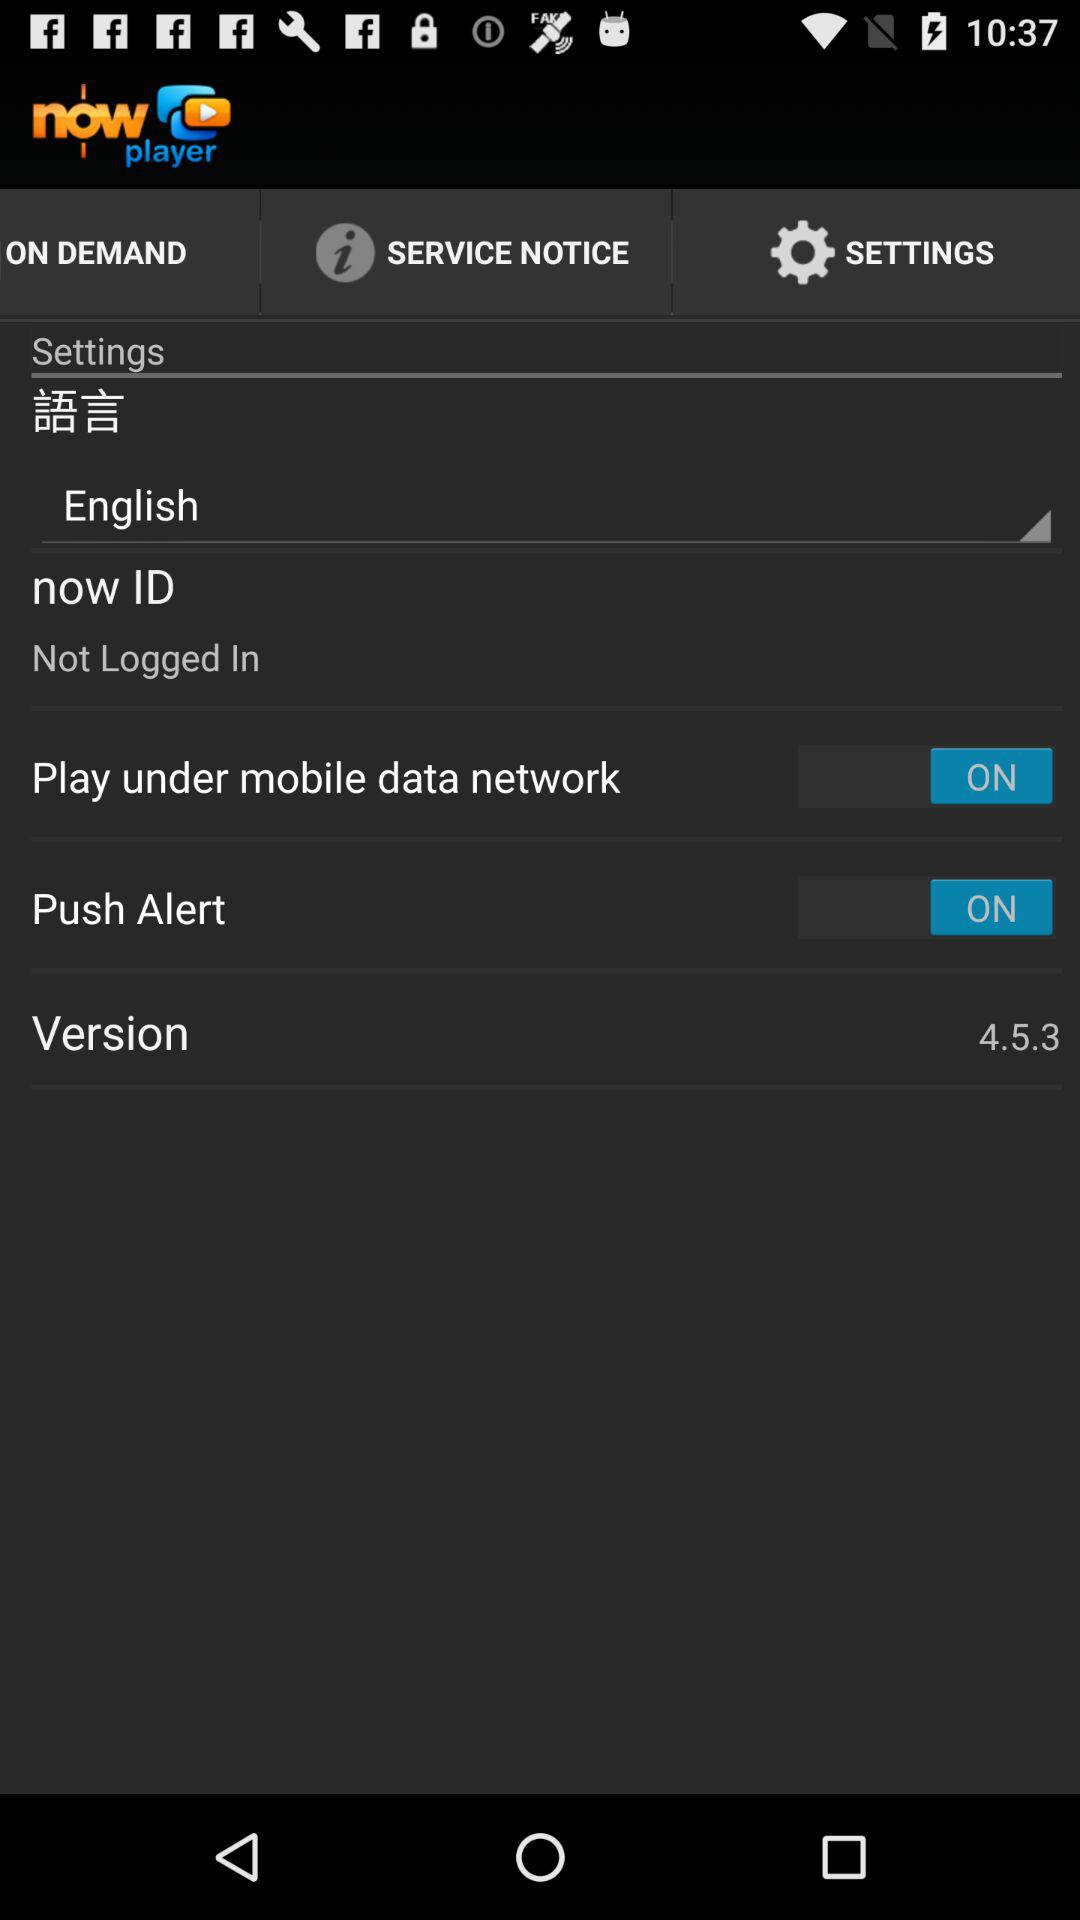What is the setting for "Play under mobile data network"? The setting is "ON". 